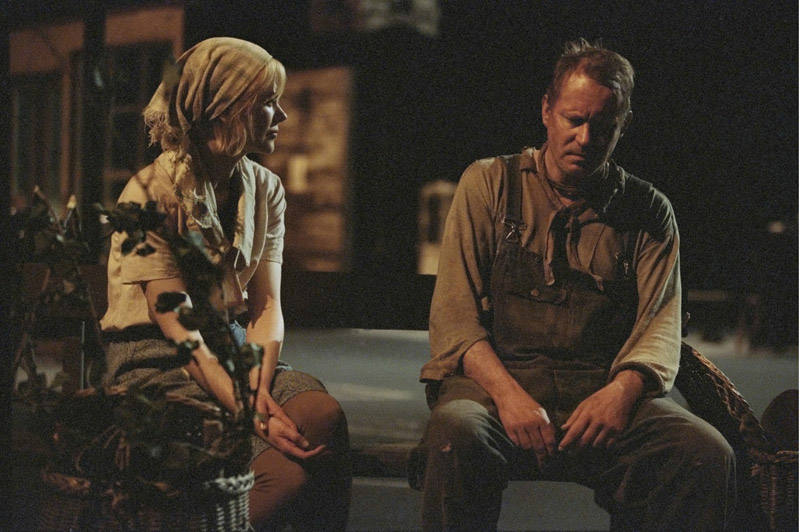What could be the backstory of the older man in this image? Tom Willis was once a renowned craftsman in his small town, known for creating the finest wooden furniture. His hands, now calloused and worn, had built dreams out of timber for many families. However, time had not been kind to Tom. The death of his wife left an irreplaceable void, and the subsequent decline of his business weighed heavily on his heart. This image captures Tom in a rare moment of vulnerability, confiding in his daughter, Emily, about the burdens he has kept hidden. Despite his stoic exterior forged by years of hardship, this moment reveals the depth of his sorrow and the strength it took to endure. Can you extend this narrative? Tom Willis's journey is one of unsung perseverance. After his wife's untimely passing, he spent days and nights in his workshop, the rhythmic sound of his carving tools offering solace. But as years went by, the demand for handcrafted furniture dwindled, replaced by cheaper, mass-produced alternatives. Tom's shop, once the heart of the community, became a shadow of its former glory. His daughter, Emily, had inherited his stubborn resolve and artistic eye. She pursued her passion for painting, often capturing the essence of their town on canvas. However, Emily’s true masterpiece was not on canvas but in her undying support for her father. On numerous evenings, they sat together on that bench, discussing dreams and sorrows, her presence a beacon in his darkest hours. With each passing day, Emily devised new ways to revive the family business. She began incorporating her paintings into the furniture, creating unique pieces of functional art. Slowly but surely, word spread, and customers returned, drawn by the fusion of art and craftsmanship. Tom watched with pride as Emily breathed new life into his legacy, her love and dedication a testament to the enduring bond between father and daughter. Imagine if the man's character was based on a mythical figure. In an ancient realm shrouded in myth and legend, there existed a being known as Theren, the Eternal Keeper of the Forests. Theren's task was to maintain the balance between nature and the encroaching civilizations. For centuries, his ageless eyes had witnessed the rise and fall of empires, each leaving their mark on the land he so meticulously protected. With his enchanted overalls, imbued with the power of the Earth itself, Theren could command the very elements to heal the forest and sustain its creatures. Yet, even a being of such might could feel the weight of countless eons. Beside him sat Liora, a young druidess chosen by the forest spirits to be his apprentice. Her blue and white garb contrasted sharply with Theren's earthy attire. She knelt beside him, sensing his weariness. 'The forest is changing, Theren. We must adapt,' she spoke softly, her voice resonating with the wisdom of the ancients. Theren sighed, the burden of millennia heavy on his soul. But seeing Liora's resolve, he felt a spark of renewed purpose. Together, the ancient keeper and his youthful apprentice would face the challenges and protect the sacred balance from falling into chaos. 